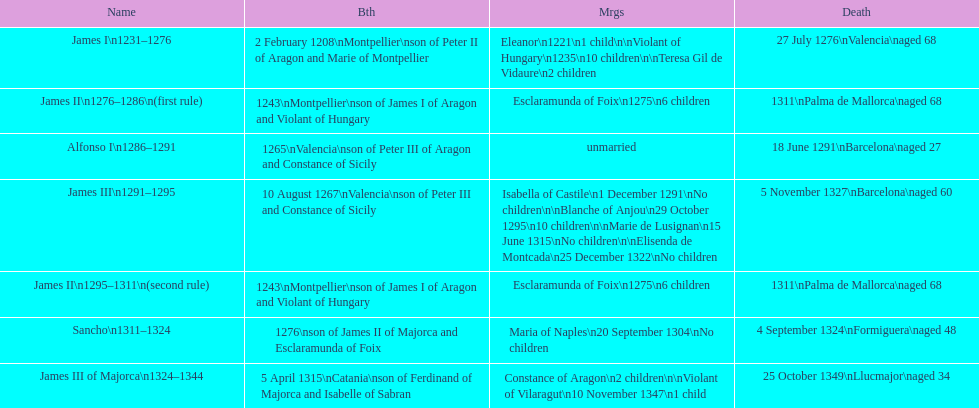Was james iii or sancho born in the year 1276? Sancho. 